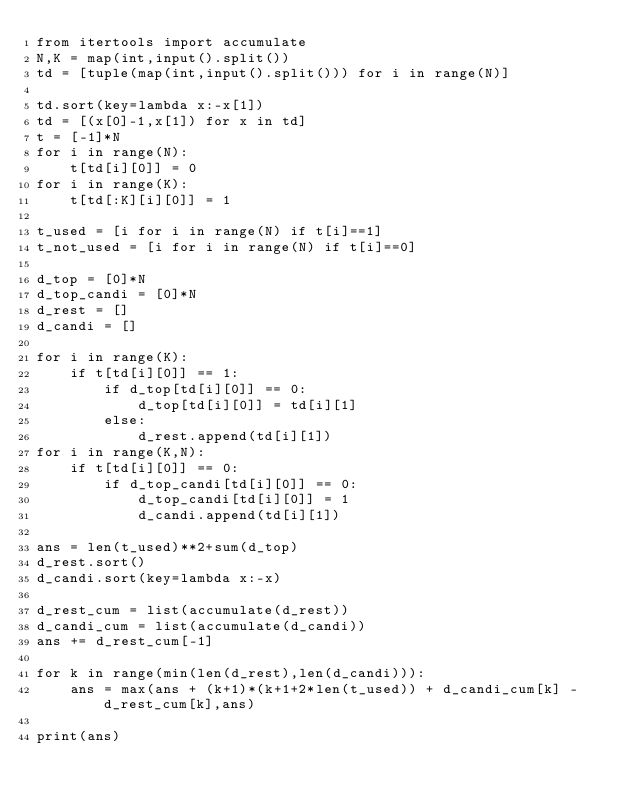Convert code to text. <code><loc_0><loc_0><loc_500><loc_500><_Python_>from itertools import accumulate
N,K = map(int,input().split())
td = [tuple(map(int,input().split())) for i in range(N)]

td.sort(key=lambda x:-x[1])
td = [(x[0]-1,x[1]) for x in td]
t = [-1]*N
for i in range(N):
    t[td[i][0]] = 0
for i in range(K):
    t[td[:K][i][0]] = 1

t_used = [i for i in range(N) if t[i]==1]
t_not_used = [i for i in range(N) if t[i]==0]

d_top = [0]*N
d_top_candi = [0]*N
d_rest = []
d_candi = []

for i in range(K):
    if t[td[i][0]] == 1:
        if d_top[td[i][0]] == 0:
            d_top[td[i][0]] = td[i][1]
        else:
            d_rest.append(td[i][1])
for i in range(K,N):
    if t[td[i][0]] == 0:
        if d_top_candi[td[i][0]] == 0:
            d_top_candi[td[i][0]] = 1
            d_candi.append(td[i][1])

ans = len(t_used)**2+sum(d_top)
d_rest.sort()
d_candi.sort(key=lambda x:-x)

d_rest_cum = list(accumulate(d_rest))
d_candi_cum = list(accumulate(d_candi))
ans += d_rest_cum[-1]

for k in range(min(len(d_rest),len(d_candi))):
    ans = max(ans + (k+1)*(k+1+2*len(t_used)) + d_candi_cum[k] - d_rest_cum[k],ans)

print(ans)</code> 